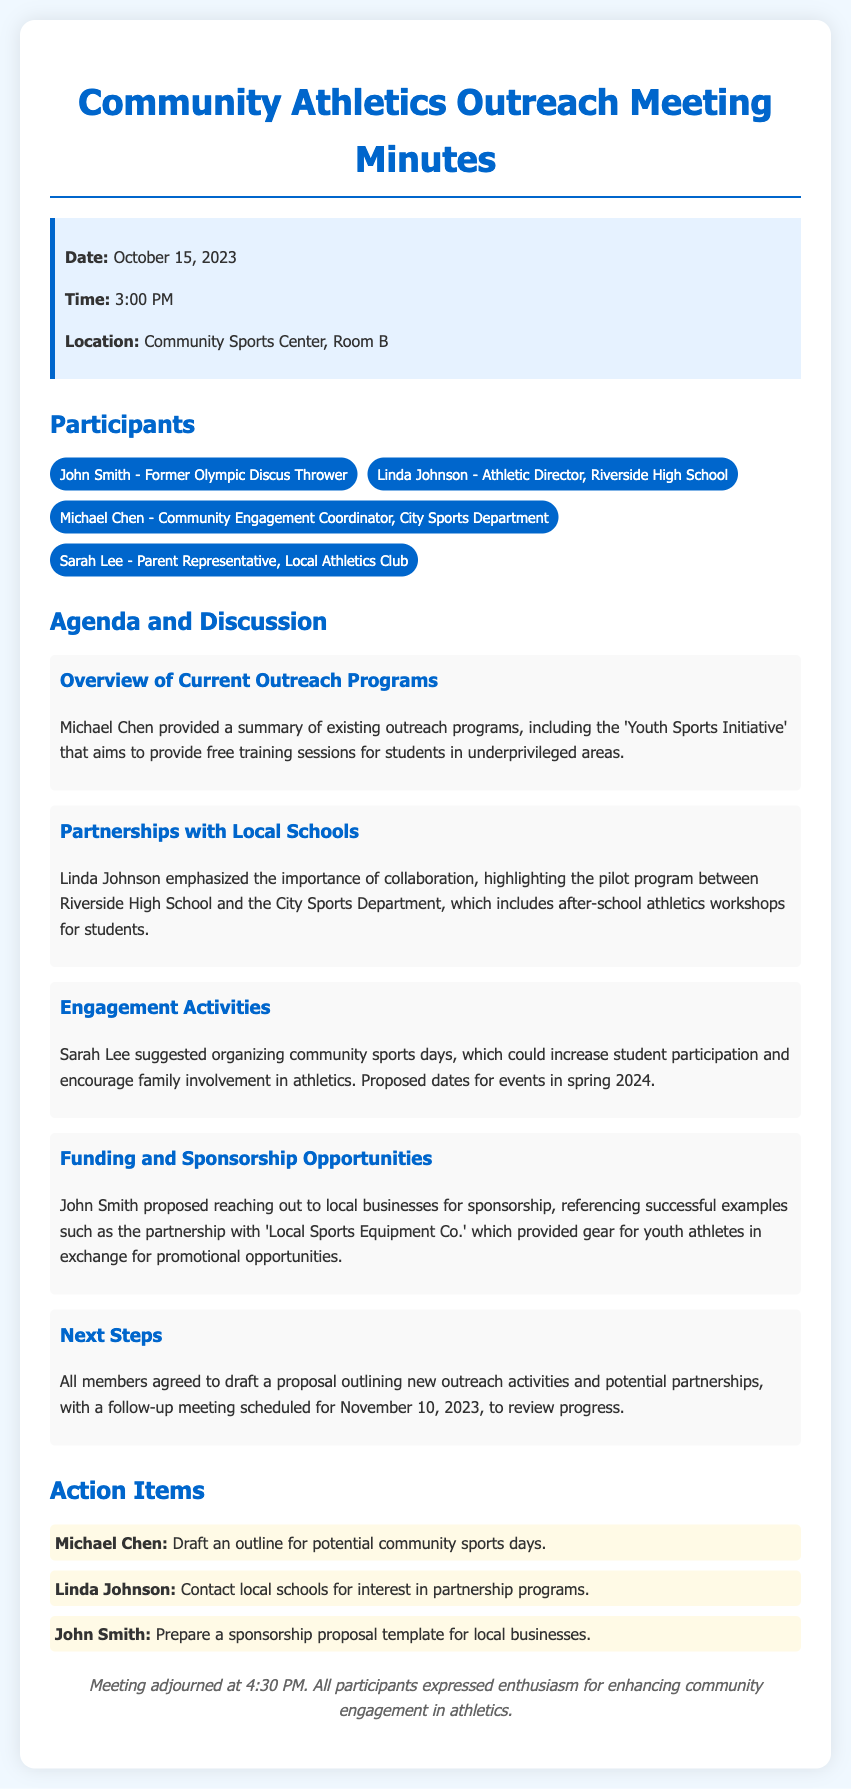what is the date of the meeting? The date of the meeting is clearly stated in the document.
Answer: October 15, 2023 who is the former Olympic discus thrower mentioned? The document lists participants, including John Smith, who is identified as the former Olympic discus thrower.
Answer: John Smith what is the main initiative discussed regarding outreach programs? The document summarizes existing outreach programs, focusing on the initiative that provides training sessions for students.
Answer: Youth Sports Initiative what partnership program is highlighted in the discussion? The document mentions a specific collaboration that is part of the outreach efforts between a school and the City Sports Department.
Answer: pilot program between Riverside High School and the City Sports Department what engagement activity was suggested by Sarah Lee? The document includes a suggestion for an activity that promotes community sports involvement.
Answer: community sports days when is the follow-up meeting scheduled? The document specifies the date for the next meeting to review progress and proposals.
Answer: November 10, 2023 who is responsible for drafting the outline for community sports days? The document lists action items and the individual tasked with drafting this outline.
Answer: Michael Chen what is the proposed focus of the sponsorship opportunities? The discussion included specifics about local businesses providing support for youth athletes.
Answer: promotional opportunities 